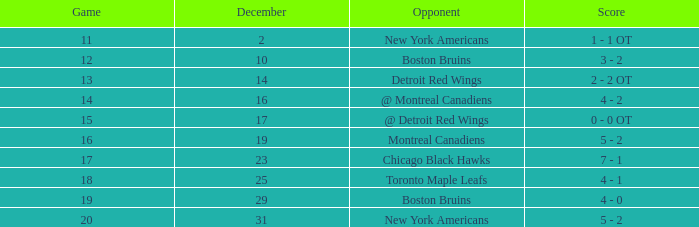Which Game is the highest one that has a Record of 4-3-6? 13.0. 